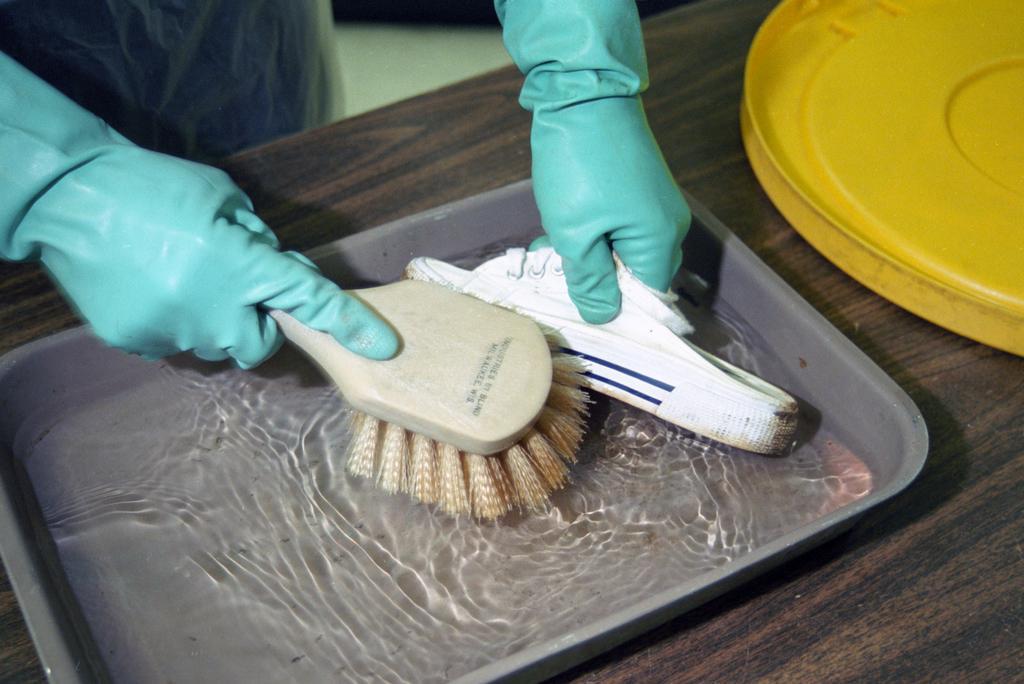Could you give a brief overview of what you see in this image? In this image I can see a person wearing blue color gloves. He is holding something. I can see a water in tray. I can see a yellow color object on the table. 